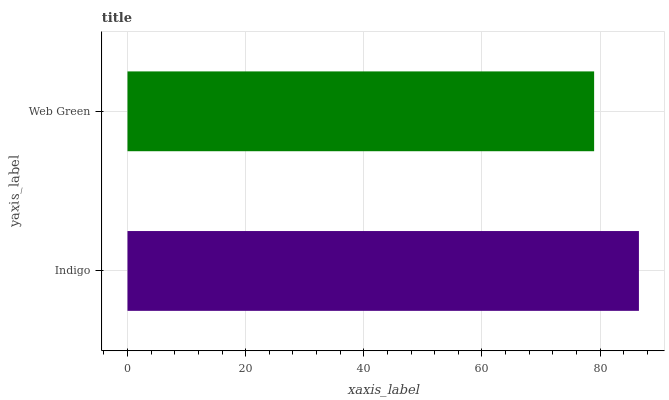Is Web Green the minimum?
Answer yes or no. Yes. Is Indigo the maximum?
Answer yes or no. Yes. Is Web Green the maximum?
Answer yes or no. No. Is Indigo greater than Web Green?
Answer yes or no. Yes. Is Web Green less than Indigo?
Answer yes or no. Yes. Is Web Green greater than Indigo?
Answer yes or no. No. Is Indigo less than Web Green?
Answer yes or no. No. Is Indigo the high median?
Answer yes or no. Yes. Is Web Green the low median?
Answer yes or no. Yes. Is Web Green the high median?
Answer yes or no. No. Is Indigo the low median?
Answer yes or no. No. 